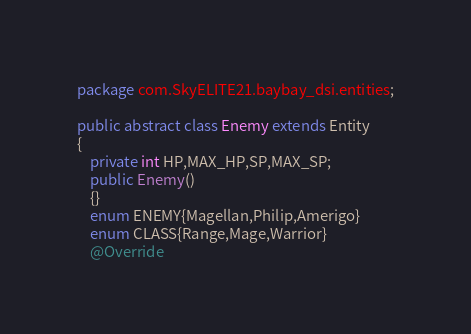Convert code to text. <code><loc_0><loc_0><loc_500><loc_500><_Java_>package com.SkyELITE21.baybay_dsi.entities;

public abstract class Enemy extends Entity
{
	private int HP,MAX_HP,SP,MAX_SP;
	public Enemy()
	{}
	enum ENEMY{Magellan,Philip,Amerigo}
	enum CLASS{Range,Mage,Warrior}
	@Override</code> 